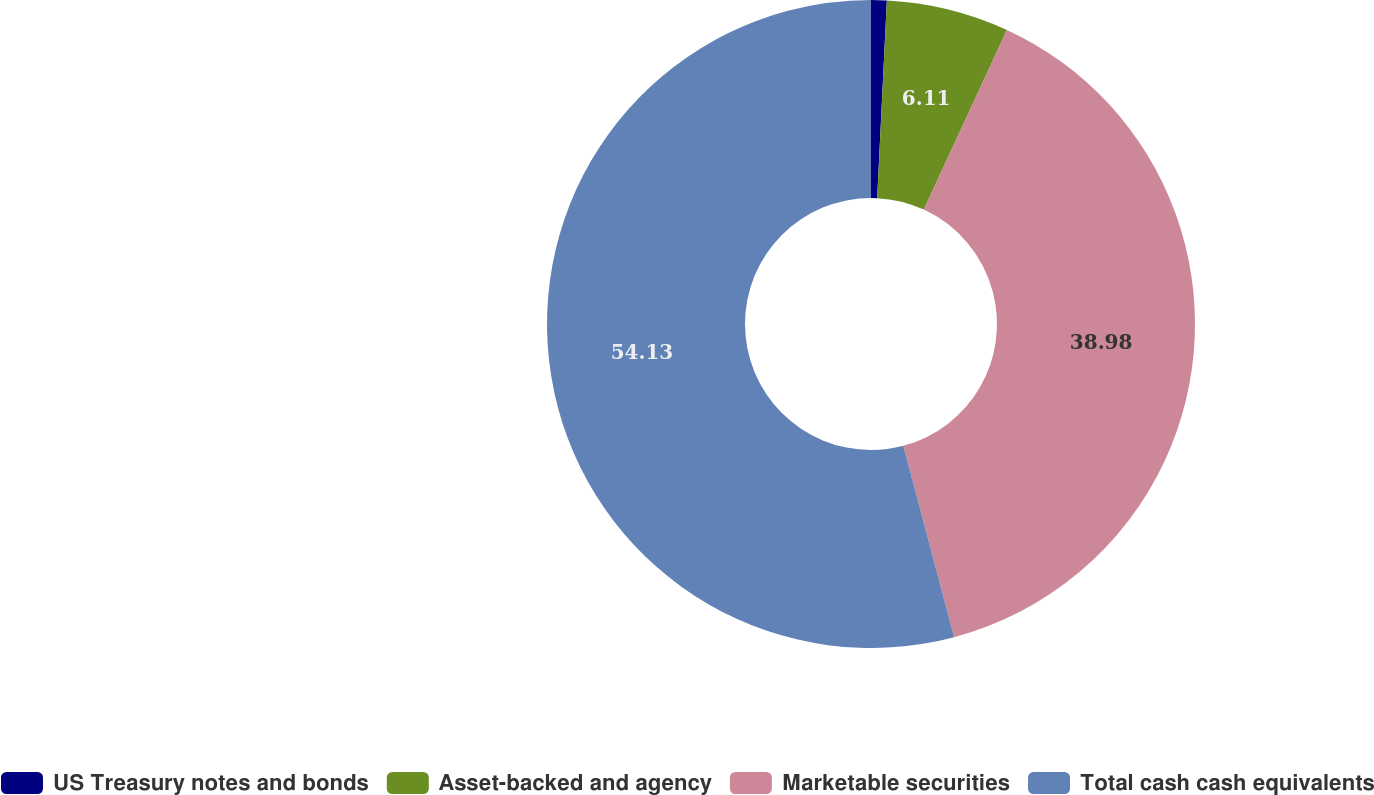Convert chart. <chart><loc_0><loc_0><loc_500><loc_500><pie_chart><fcel>US Treasury notes and bonds<fcel>Asset-backed and agency<fcel>Marketable securities<fcel>Total cash cash equivalents<nl><fcel>0.78%<fcel>6.11%<fcel>38.98%<fcel>54.13%<nl></chart> 